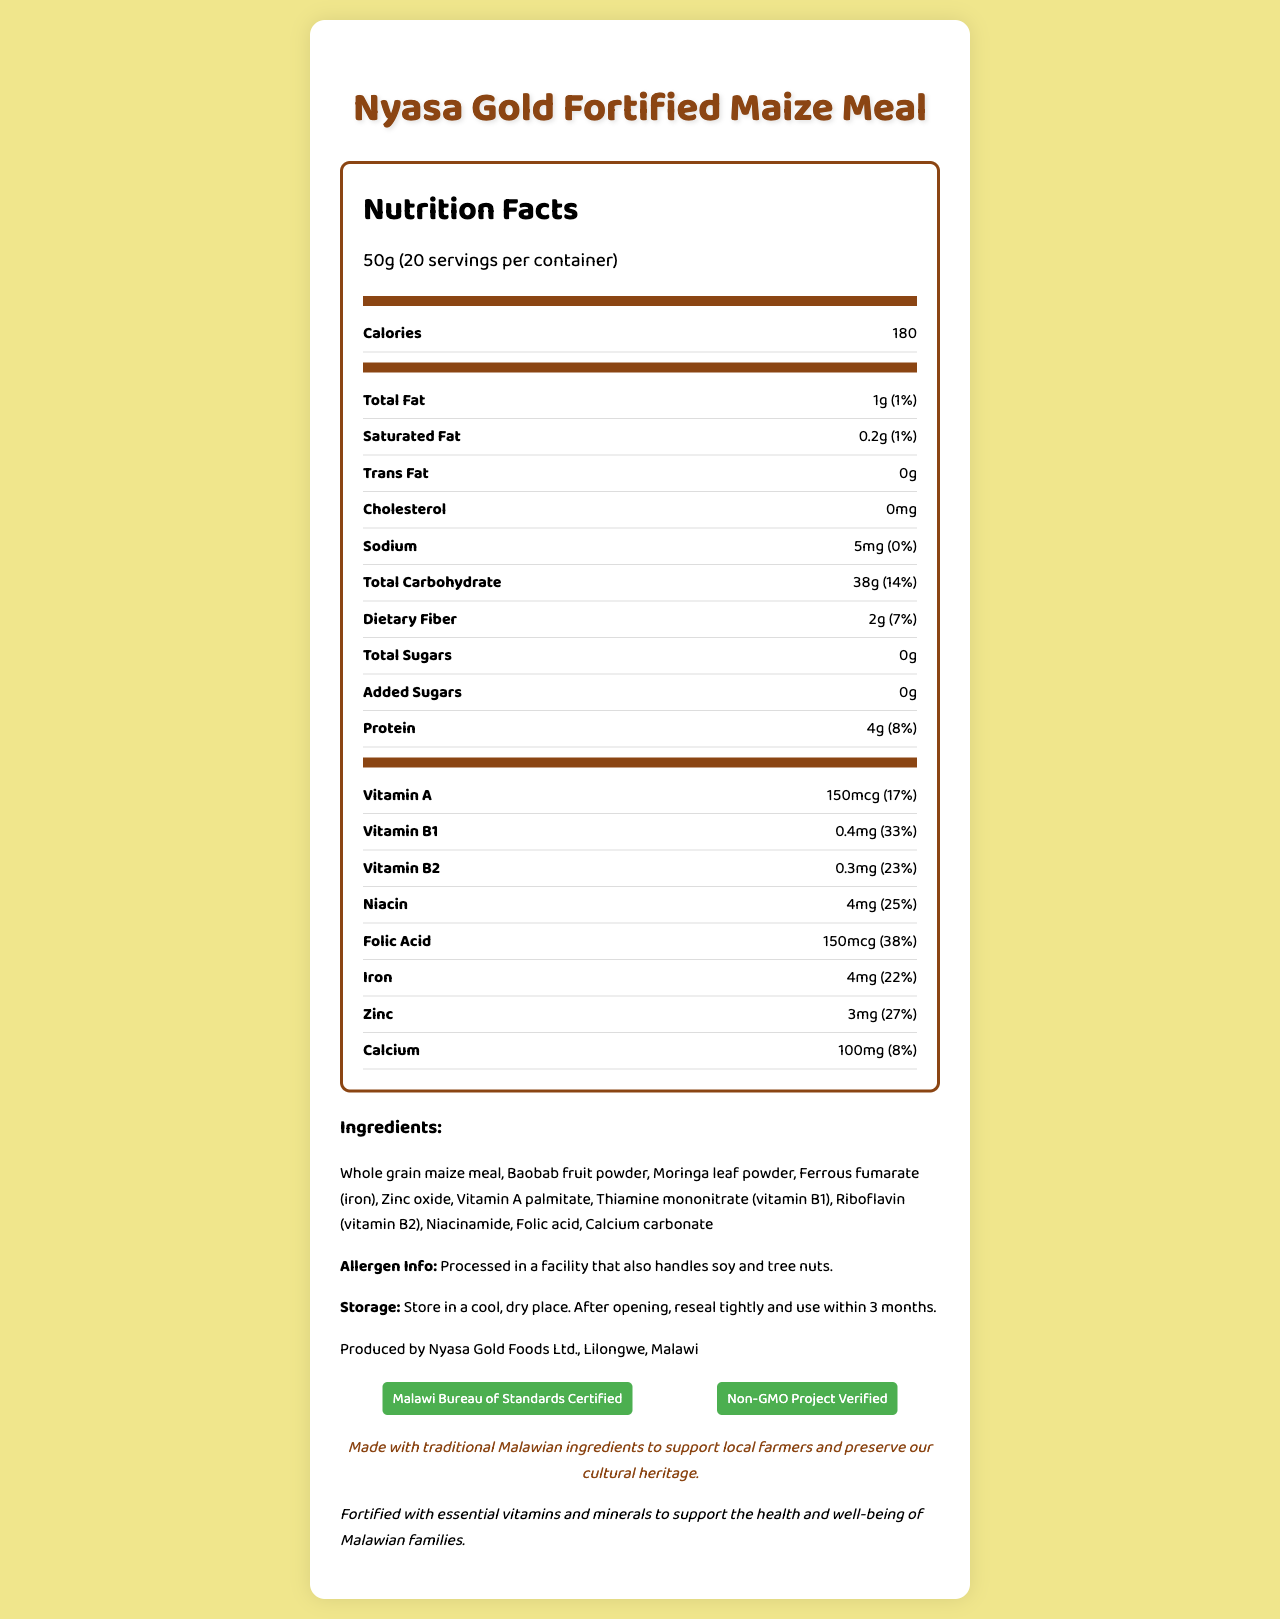What is the serving size of Nyasa Gold Fortified Maize Meal? The serving size is clearly mentioned at the beginning of the nutrition facts section as "50g".
Answer: 50g How many servings are there per container? The number of servings per container is specified right below the serving size as "20".
Answer: 20 How many calories does one serving of Nyasa Gold Fortified Maize Meal provide? The calories per serving are listed under the "Calories" section as "180".
Answer: 180 What are the main ingredients of this fortified maize meal? The ingredients are listed in the ingredients section which includes "Whole grain maize meal, Baobab fruit powder, Moringa leaf powder".
Answer: Whole grain maize meal, Baobab fruit powder, Moringa leaf powder What vitamins and minerals are used to fortify Nyasa Gold Fortified Maize Meal? The vitamins and minerals used for fortification are mentioned under their respective amounts and daily values in the nutrient section.
Answer: Vitamin A, Vitamin B1, Vitamin B2, Niacin, Folic Acid, Iron, Zinc, Calcium What is the percent daily value of Vitamin B1 in a serving? The percent daily value of Vitamin B1 is shown next to its amount in the nutrient section as "33%".
Answer: 33% What is the storage instruction for this product? The storage instructions are given towards the end of the label as "Store in a cool, dry place. After opening, reseal tightly and use within 3 months."
Answer: Store in a cool, dry place. After opening, reseal tightly and use within 3 months. Processed in a facility that also handles what allergens? The allergen information mentions that the product is processed in a facility that also handles soy and tree nuts.
Answer: Soy and tree nuts List the certifications of Nyasa Gold Fortified Maize Meal. The certifications section lists "Malawi Bureau of Standards Certified" and "Non-GMO Project Verified".
Answer: Malawi Bureau of Standards Certified, Non-GMO Project Verified Which of the following is NOT an ingredient in Nyasa Gold Fortified Maize Meal? A. Whole grain maize meal B. Ferrous fumarate C. Vitamin C D. Moringa leaf powder Vitamin C is not listed among the ingredients found in the ingredients section.
Answer: C. Vitamin C How much protein is there in one serving of Nyasa Gold Fortified Maize Meal? A. 2g B. 3g C. 4g D. 5g The protein content per serving is listed clearly under the nutrients section as "4g".
Answer: C. 4g Does this product contain any added sugars? The document lists the amounts for "Total Sugars" and "Added Sugars" with the amount of "0g" for added sugars.
Answer: No Is the product enriched with traditional Malawian ingredients? The traditional claim statement clearly mentions that the product is "Made with traditional Malawian ingredients."
Answer: Yes What is the main focus of this document? The document provides a detailed breakdown of nutritional information, ingredients list, allergen information, certifications, and traditional and fortification claims.
Answer: The main focus of the document is to provide detailed nutrition facts for Nyasa Gold Fortified Maize Meal, including serving size, caloric content, and amounts and daily values of various nutrients, while emphasizing its fortification with essential vitamins and minerals, traditional ingredients, certifications, and storage instructions. Which company produces Nyasa Gold Fortified Maize Meal? The manufacturer's information clearly states "Produced by Nyasa Gold Foods Ltd., Lilongwe, Malawi".
Answer: Nyasa Gold Foods Ltd., Lilongwe, Malawi How much iron does each serving contain? The iron content per serving is listed under the nutrients section as "4mg".
Answer: 4mg What is the fortification statement given in the document? The fortification statement is mentioned towards the end of the document.
Answer: Fortified with essential vitamins and minerals to support the health and well-being of Malawian families. What is the source of Vitamin A in this product? The document does not provide specific information on the source of Vitamin A, only listing it as "Vitamin A palmitate".
Answer: I don't know What percent of the daily value is the total carbohydrate content per serving? The document lists the total carbohydrate and its percent daily value per serving as "38g (14%)".
Answer: 14% 